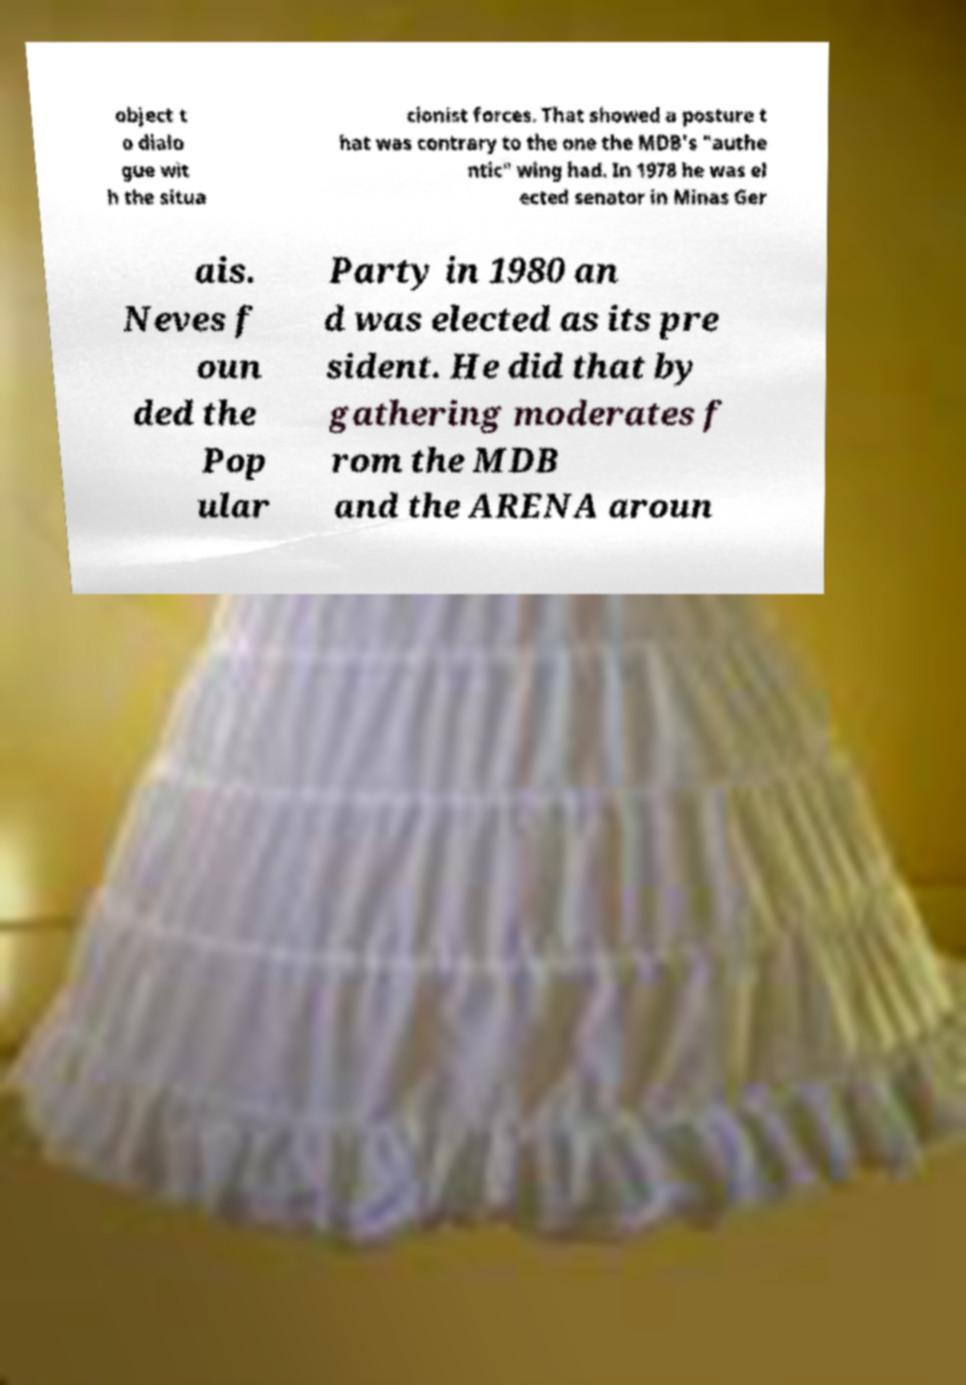Could you extract and type out the text from this image? object t o dialo gue wit h the situa cionist forces. That showed a posture t hat was contrary to the one the MDB's "authe ntic" wing had. In 1978 he was el ected senator in Minas Ger ais. Neves f oun ded the Pop ular Party in 1980 an d was elected as its pre sident. He did that by gathering moderates f rom the MDB and the ARENA aroun 